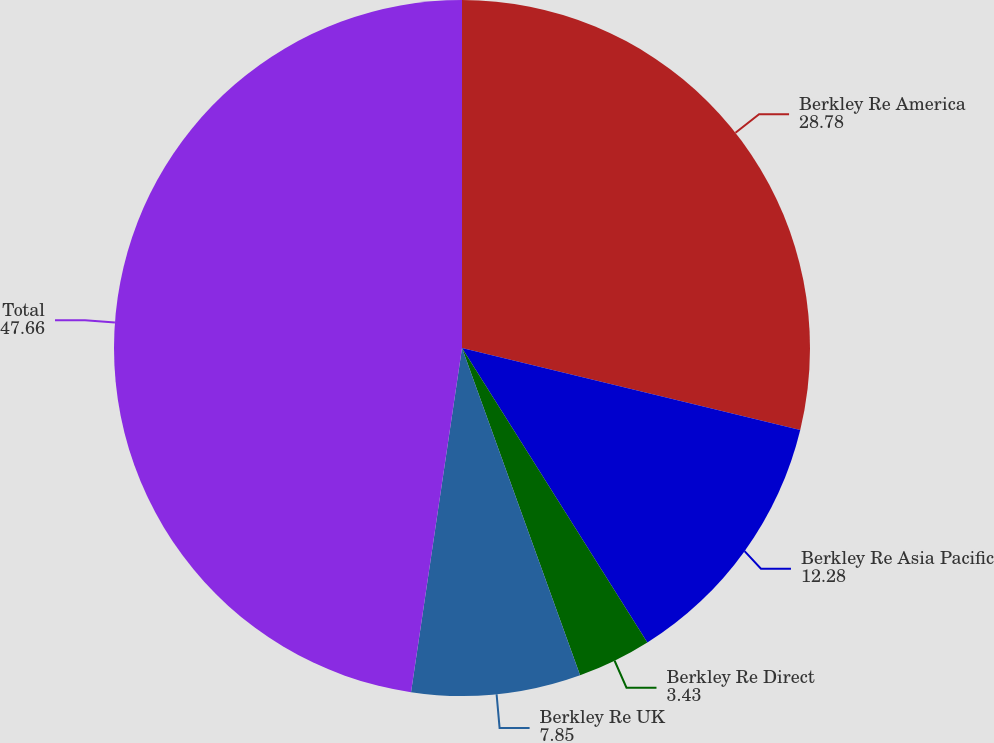Convert chart. <chart><loc_0><loc_0><loc_500><loc_500><pie_chart><fcel>Berkley Re America<fcel>Berkley Re Asia Pacific<fcel>Berkley Re Direct<fcel>Berkley Re UK<fcel>Total<nl><fcel>28.78%<fcel>12.28%<fcel>3.43%<fcel>7.85%<fcel>47.66%<nl></chart> 